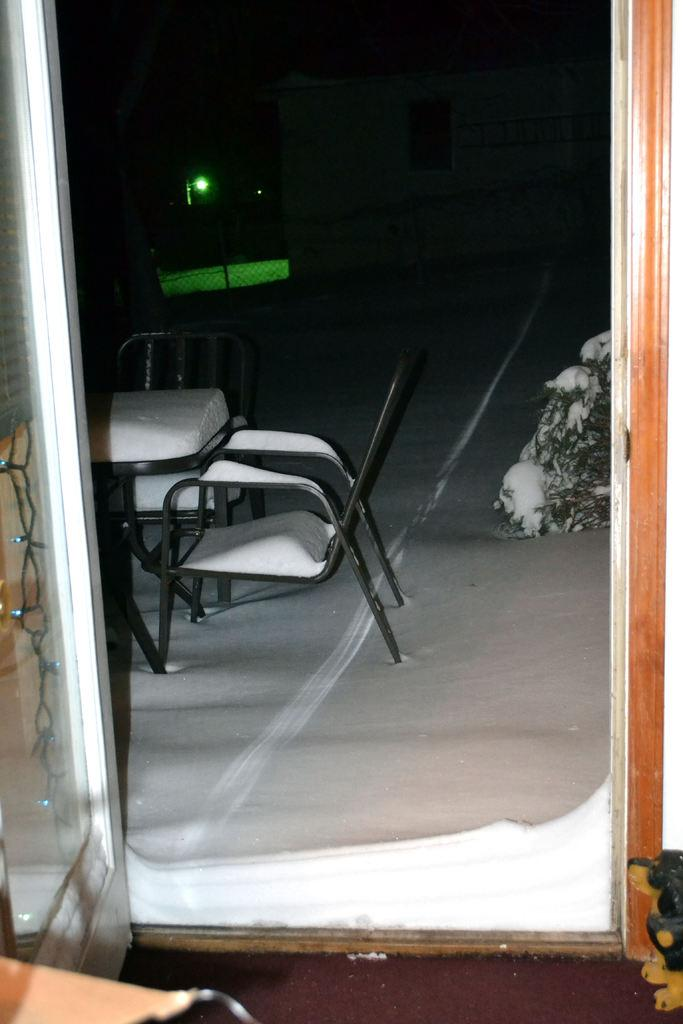What is located in the middle of the image? There is an entrance in the middle of the image. What type of furniture can be seen in the image? There is a chair in the image. What other object is present in the image? There is a table in the image. How does the entrance rub against the chair in the image? The entrance does not rub against the chair in the image; they are separate objects. 